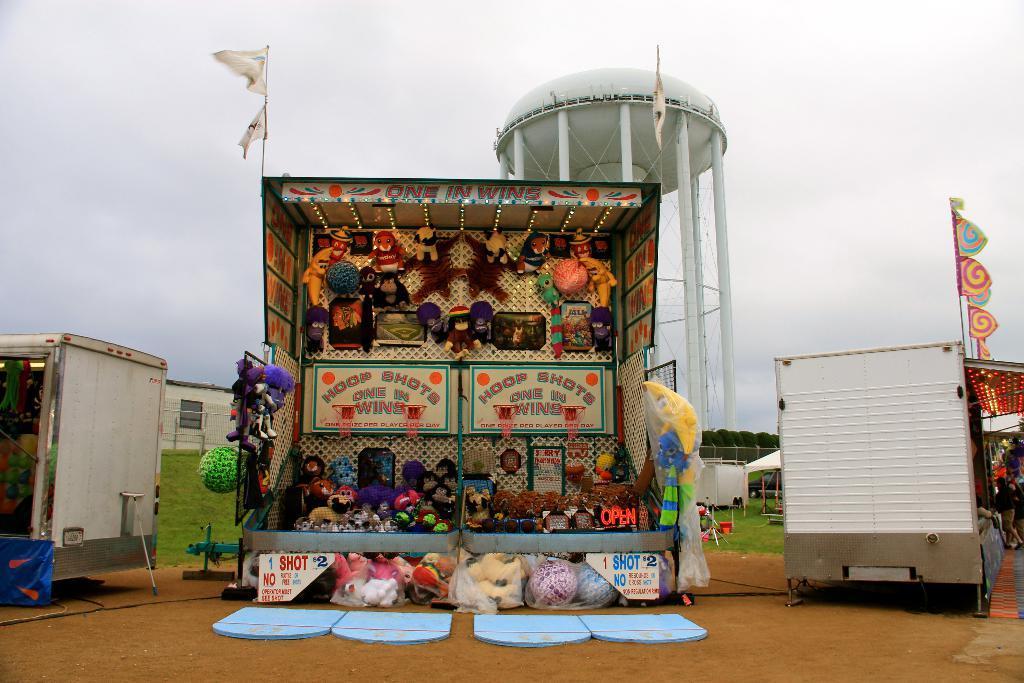How would you summarize this image in a sentence or two? In this picture we can see the sheds, tent, house, fencing, grass, toys, flags, poles and some other objects. In the center of the image we can see a tower and pillars. In the background of the image we can see the wires and trees. At the bottom of the image we can see the ground. At the top of the image we can see the sky. 